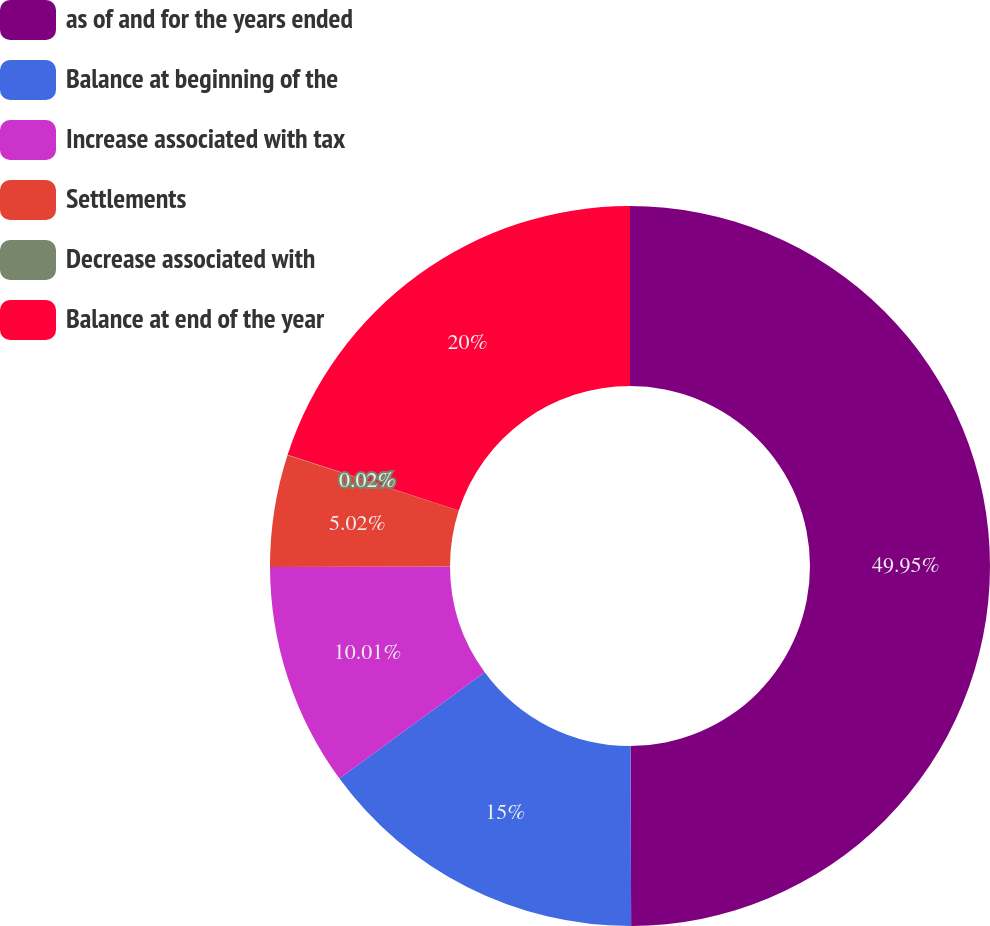Convert chart to OTSL. <chart><loc_0><loc_0><loc_500><loc_500><pie_chart><fcel>as of and for the years ended<fcel>Balance at beginning of the<fcel>Increase associated with tax<fcel>Settlements<fcel>Decrease associated with<fcel>Balance at end of the year<nl><fcel>49.95%<fcel>15.0%<fcel>10.01%<fcel>5.02%<fcel>0.02%<fcel>20.0%<nl></chart> 